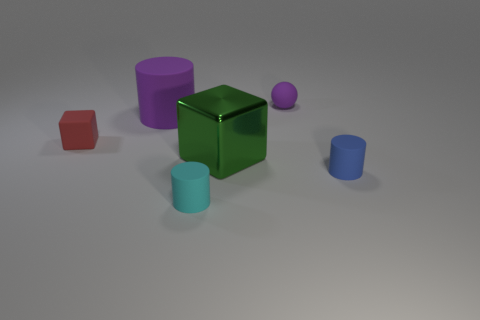How many objects in the image have a cylindrical shape? In the image, there are two objects that have a cylindrical shape: one is a shorter, teal-colored cylinder, and the other is a taller, blue one. 